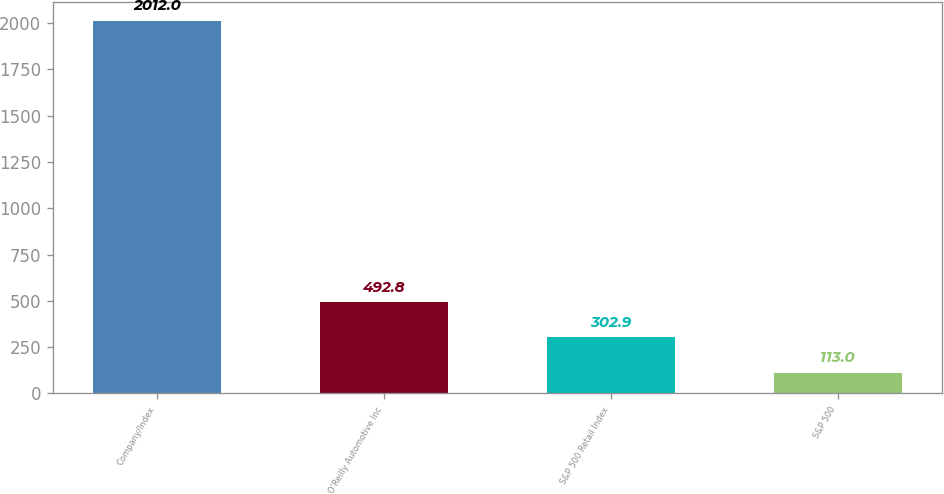<chart> <loc_0><loc_0><loc_500><loc_500><bar_chart><fcel>Company/Index<fcel>O'Reilly Automotive Inc<fcel>S&P 500 Retail Index<fcel>S&P 500<nl><fcel>2012<fcel>492.8<fcel>302.9<fcel>113<nl></chart> 